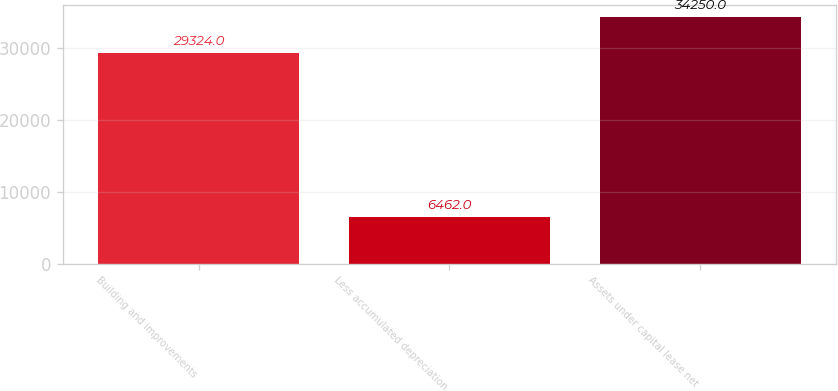Convert chart to OTSL. <chart><loc_0><loc_0><loc_500><loc_500><bar_chart><fcel>Building and improvements<fcel>Less accumulated depreciation<fcel>Assets under capital lease net<nl><fcel>29324<fcel>6462<fcel>34250<nl></chart> 